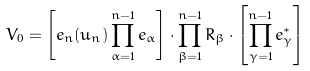<formula> <loc_0><loc_0><loc_500><loc_500>V _ { 0 } = \left [ e _ { n } ( u _ { n } ) \prod _ { \alpha = 1 } ^ { n - 1 } e _ { \alpha } \right ] \cdot \prod _ { \beta = 1 } ^ { n - 1 } R _ { \beta } \cdot \left [ \prod _ { \gamma = 1 } ^ { n - 1 } e _ { \gamma } ^ { * } \right ]</formula> 